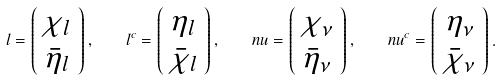Convert formula to latex. <formula><loc_0><loc_0><loc_500><loc_500>l = \left ( \begin{array} { c } \chi _ { l } \\ \bar { \eta } _ { l } \end{array} \right ) , \quad l ^ { c } = \left ( \begin{array} { c } \eta _ { l } \\ \bar { \chi } _ { l } \end{array} \right ) , \quad n u = \left ( \begin{array} { c } \chi _ { \nu } \\ \bar { \eta } _ { \nu } \end{array} \right ) , \quad n u ^ { c } = \left ( \begin{array} { c } \eta _ { \nu } \\ \bar { \chi } _ { \nu } \end{array} \right ) .</formula> 